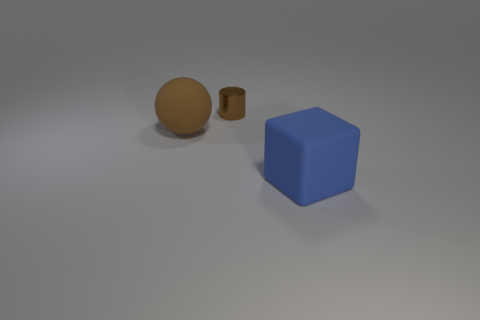How many objects are there, and can you describe their shapes? There are three objects in the image: a large spherical ball, a smaller cylinder, both with a matte finish, and a larger cube with a different texture that has a bit of a sheen to it. 